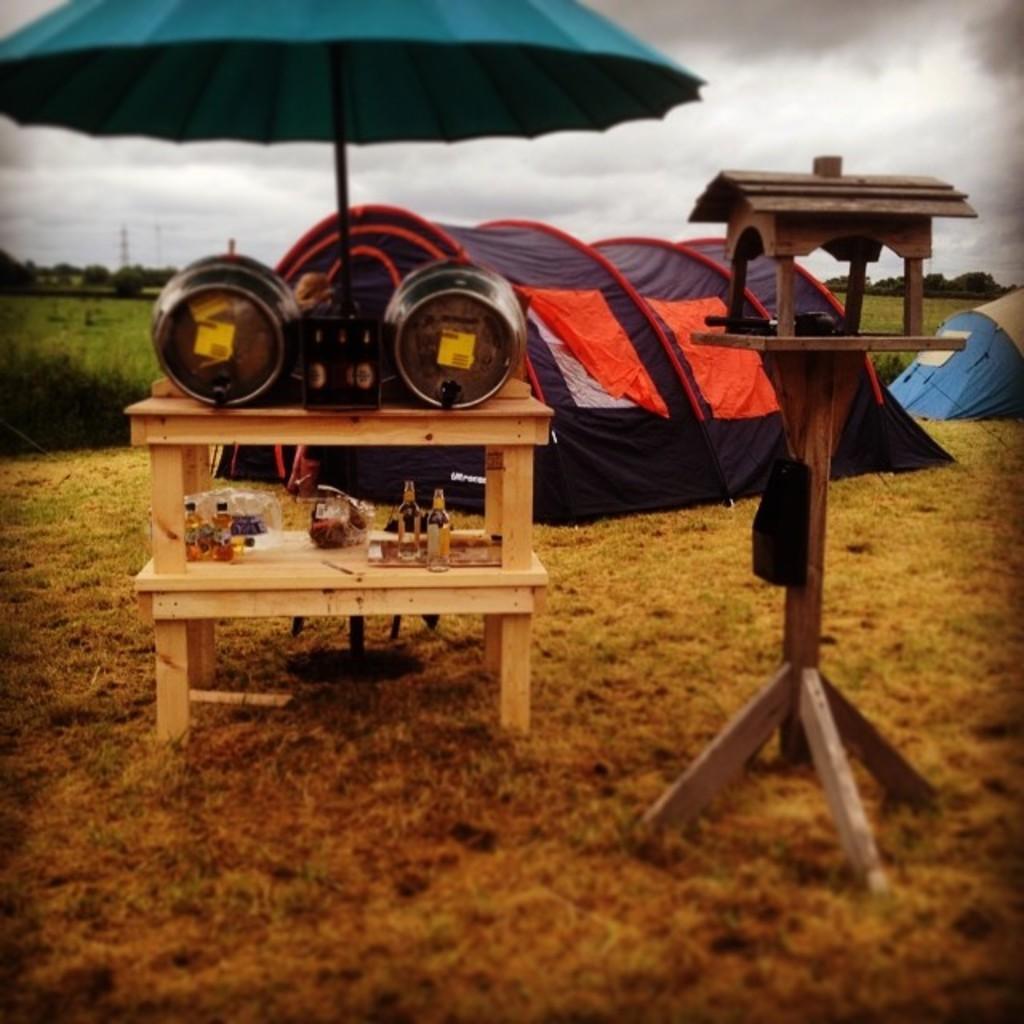In one or two sentences, can you explain what this image depicts? In this image I can see few objects on the wooden racks. I can see an umbrella,tents and wooden object. Back I can see few trees. The sky is in white color. 